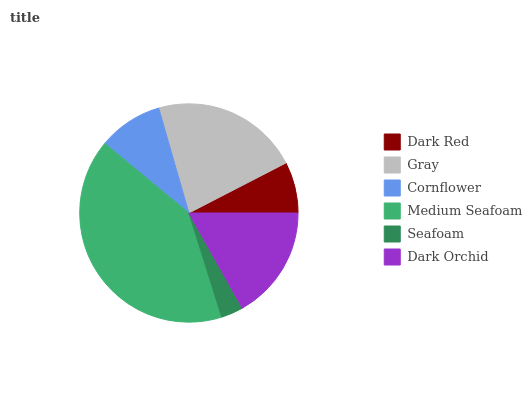Is Seafoam the minimum?
Answer yes or no. Yes. Is Medium Seafoam the maximum?
Answer yes or no. Yes. Is Gray the minimum?
Answer yes or no. No. Is Gray the maximum?
Answer yes or no. No. Is Gray greater than Dark Red?
Answer yes or no. Yes. Is Dark Red less than Gray?
Answer yes or no. Yes. Is Dark Red greater than Gray?
Answer yes or no. No. Is Gray less than Dark Red?
Answer yes or no. No. Is Dark Orchid the high median?
Answer yes or no. Yes. Is Cornflower the low median?
Answer yes or no. Yes. Is Medium Seafoam the high median?
Answer yes or no. No. Is Gray the low median?
Answer yes or no. No. 